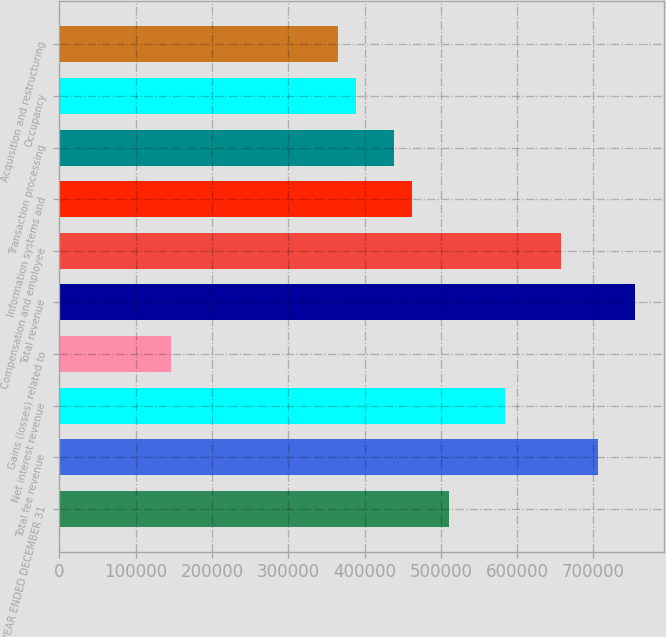Convert chart. <chart><loc_0><loc_0><loc_500><loc_500><bar_chart><fcel>FOR THE YEAR ENDED DECEMBER 31<fcel>Total fee revenue<fcel>Net interest revenue<fcel>Gains (losses) related to<fcel>Total revenue<fcel>Compensation and employee<fcel>Information systems and<fcel>Transaction processing<fcel>Occupancy<fcel>Acquisition and restructuring<nl><fcel>510910<fcel>705542<fcel>583897<fcel>145975<fcel>754200<fcel>656884<fcel>462252<fcel>437923<fcel>389265<fcel>364936<nl></chart> 